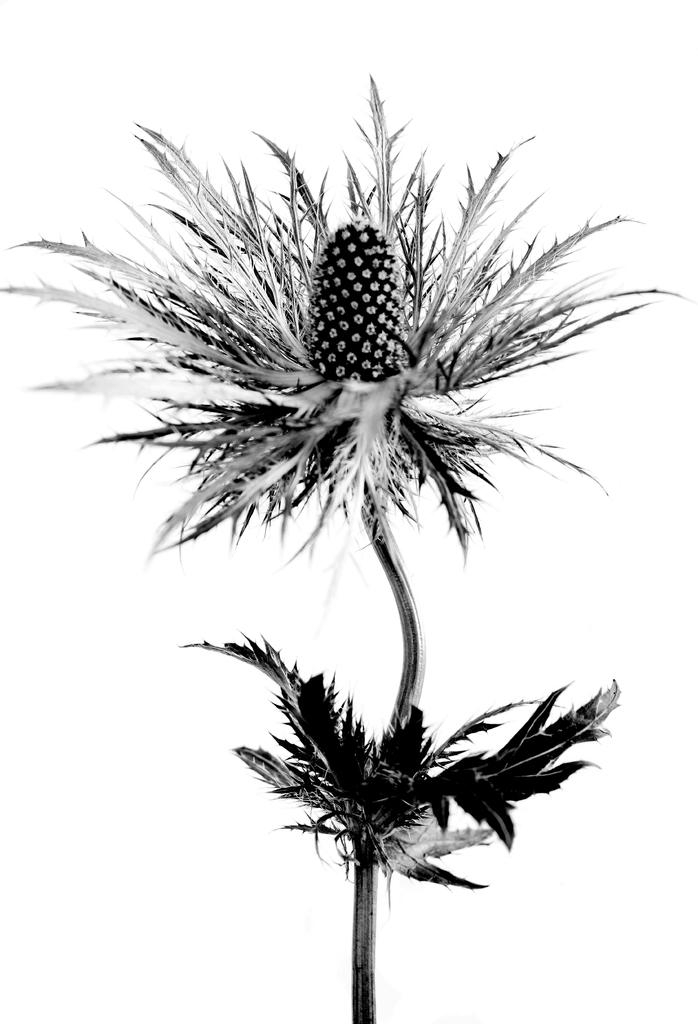What is the color scheme of the image? The image is black and white. What is the main subject of the image? The image depicts a flower. What color is the background of the image? The background of the image is white. Can you see a beetle crawling on the flower in the image? There is no beetle present in the image. What type of harmony is being depicted in the image? The image does not depict any specific type of harmony; it simply shows a flower against a white background. 